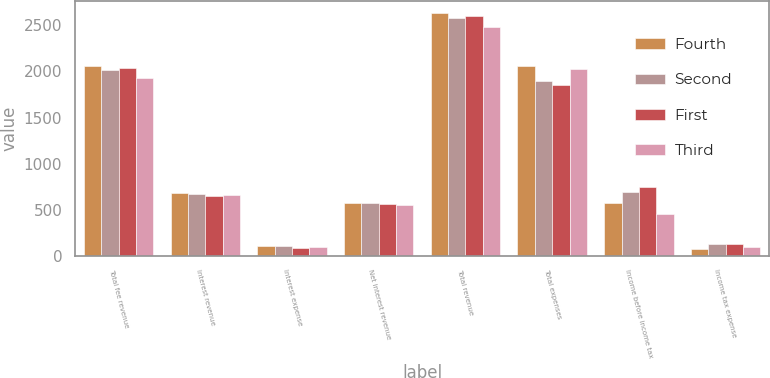<chart> <loc_0><loc_0><loc_500><loc_500><stacked_bar_chart><ecel><fcel>Total fee revenue<fcel>Interest revenue<fcel>Interest expense<fcel>Net interest revenue<fcel>Total revenue<fcel>Total expenses<fcel>Income before income tax<fcel>Income tax expense<nl><fcel>Fourth<fcel>2056<fcel>676<fcel>102<fcel>574<fcel>2630<fcel>2057<fcel>569<fcel>77<nl><fcel>Second<fcel>2012<fcel>671<fcel>101<fcel>570<fcel>2582<fcel>1892<fcel>688<fcel>128<nl><fcel>First<fcel>2039<fcel>650<fcel>89<fcel>561<fcel>2598<fcel>1850<fcel>746<fcel>124<nl><fcel>Third<fcel>1924<fcel>655<fcel>100<fcel>555<fcel>2485<fcel>2028<fcel>455<fcel>92<nl></chart> 